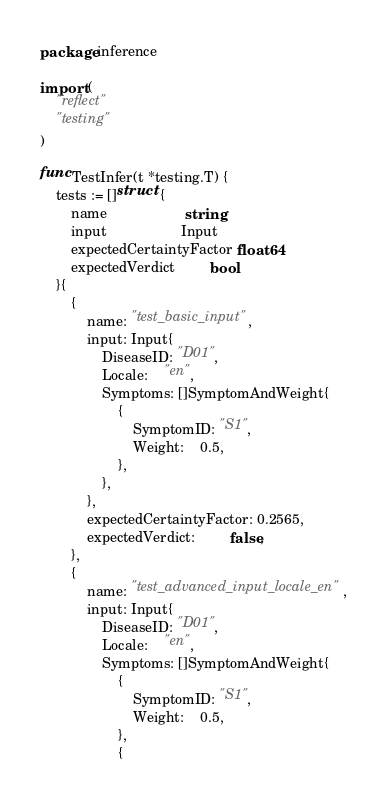Convert code to text. <code><loc_0><loc_0><loc_500><loc_500><_Go_>package inference

import (
	"reflect"
	"testing"
)

func TestInfer(t *testing.T) {
	tests := []struct {
		name                    string
		input                   Input
		expectedCertaintyFactor float64
		expectedVerdict         bool
	}{
		{
			name: "test_basic_input",
			input: Input{
				DiseaseID: "D01",
				Locale:    "en",
				Symptoms: []SymptomAndWeight{
					{
						SymptomID: "S1",
						Weight:    0.5,
					},
				},
			},
			expectedCertaintyFactor: 0.2565,
			expectedVerdict:         false,
		},
		{
			name: "test_advanced_input_locale_en",
			input: Input{
				DiseaseID: "D01",
				Locale:    "en",
				Symptoms: []SymptomAndWeight{
					{
						SymptomID: "S1",
						Weight:    0.5,
					},
					{</code> 